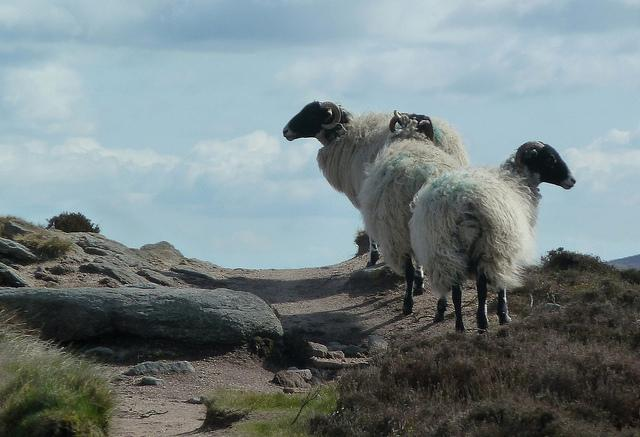What is a process that is related to these animals?

Choices:
A) nuclear fusion
B) shearing
C) soaring
D) photosynthesis shearing 